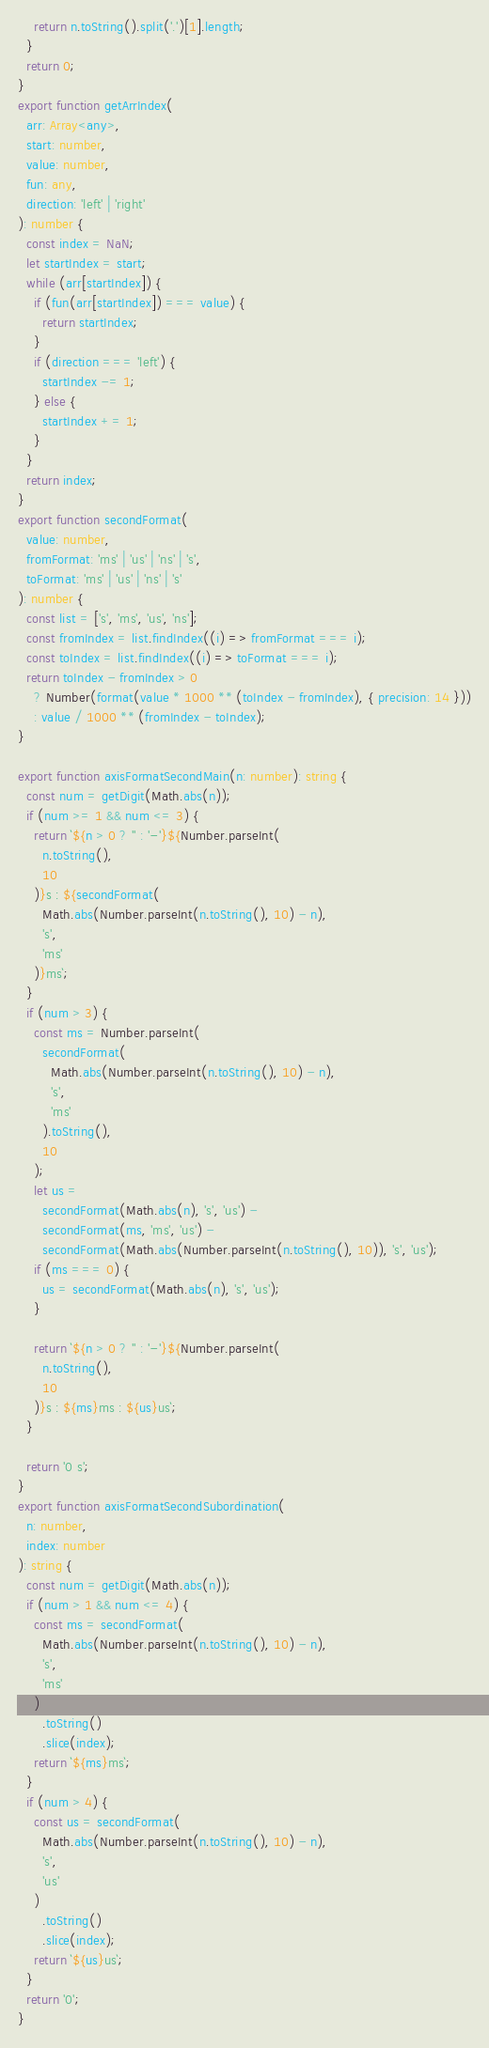Convert code to text. <code><loc_0><loc_0><loc_500><loc_500><_TypeScript_>    return n.toString().split('.')[1].length;
  }
  return 0;
}
export function getArrIndex(
  arr: Array<any>,
  start: number,
  value: number,
  fun: any,
  direction: 'left' | 'right'
): number {
  const index = NaN;
  let startIndex = start;
  while (arr[startIndex]) {
    if (fun(arr[startIndex]) === value) {
      return startIndex;
    }
    if (direction === 'left') {
      startIndex -= 1;
    } else {
      startIndex += 1;
    }
  }
  return index;
}
export function secondFormat(
  value: number,
  fromFormat: 'ms' | 'us' | 'ns' | 's',
  toFormat: 'ms' | 'us' | 'ns' | 's'
): number {
  const list = ['s', 'ms', 'us', 'ns'];
  const fromIndex = list.findIndex((i) => fromFormat === i);
  const toIndex = list.findIndex((i) => toFormat === i);
  return toIndex - fromIndex > 0
    ? Number(format(value * 1000 ** (toIndex - fromIndex), { precision: 14 }))
    : value / 1000 ** (fromIndex - toIndex);
}

export function axisFormatSecondMain(n: number): string {
  const num = getDigit(Math.abs(n));
  if (num >= 1 && num <= 3) {
    return `${n > 0 ? '' : '-'}${Number.parseInt(
      n.toString(),
      10
    )}s : ${secondFormat(
      Math.abs(Number.parseInt(n.toString(), 10) - n),
      's',
      'ms'
    )}ms`;
  }
  if (num > 3) {
    const ms = Number.parseInt(
      secondFormat(
        Math.abs(Number.parseInt(n.toString(), 10) - n),
        's',
        'ms'
      ).toString(),
      10
    );
    let us =
      secondFormat(Math.abs(n), 's', 'us') -
      secondFormat(ms, 'ms', 'us') -
      secondFormat(Math.abs(Number.parseInt(n.toString(), 10)), 's', 'us');
    if (ms === 0) {
      us = secondFormat(Math.abs(n), 's', 'us');
    }

    return `${n > 0 ? '' : '-'}${Number.parseInt(
      n.toString(),
      10
    )}s : ${ms}ms : ${us}us`;
  }

  return '0 s';
}
export function axisFormatSecondSubordination(
  n: number,
  index: number
): string {
  const num = getDigit(Math.abs(n));
  if (num > 1 && num <= 4) {
    const ms = secondFormat(
      Math.abs(Number.parseInt(n.toString(), 10) - n),
      's',
      'ms'
    )
      .toString()
      .slice(index);
    return `${ms}ms`;
  }
  if (num > 4) {
    const us = secondFormat(
      Math.abs(Number.parseInt(n.toString(), 10) - n),
      's',
      'us'
    )
      .toString()
      .slice(index);
    return `${us}us`;
  }
  return '0';
}
</code> 